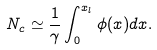Convert formula to latex. <formula><loc_0><loc_0><loc_500><loc_500>N _ { c } \simeq \frac { 1 } { \gamma } \int _ { 0 } ^ { x _ { l } } \phi ( x ) d x .</formula> 